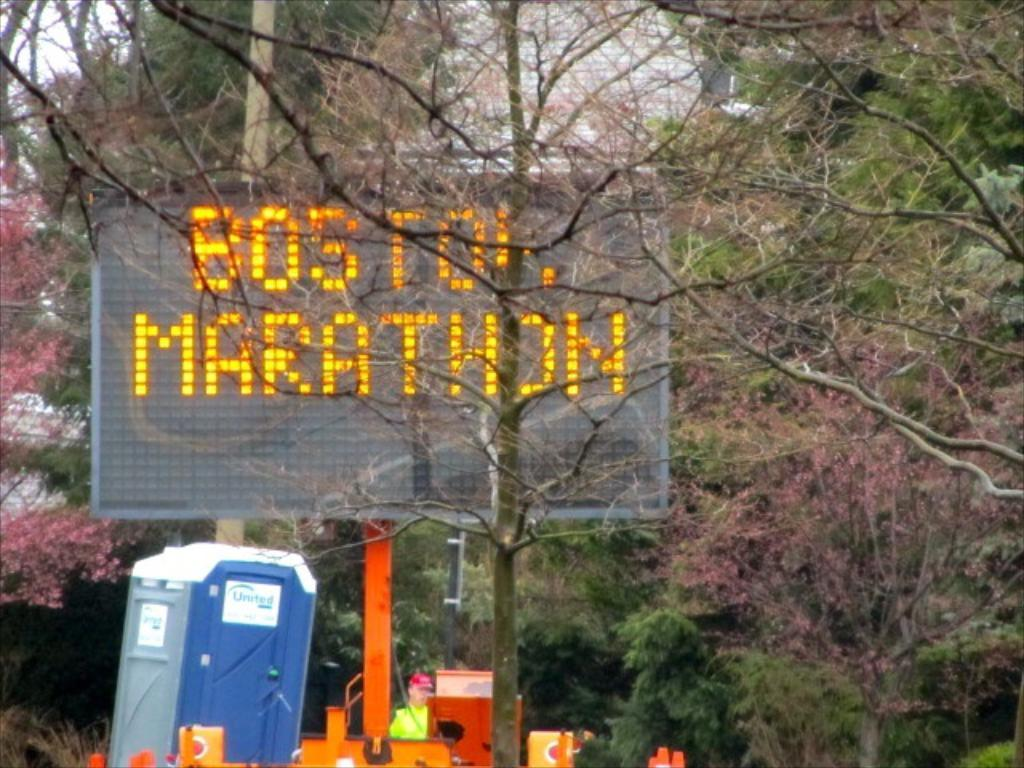<image>
Present a compact description of the photo's key features. A orange and black variable sign warning of the Boston Marathon. 